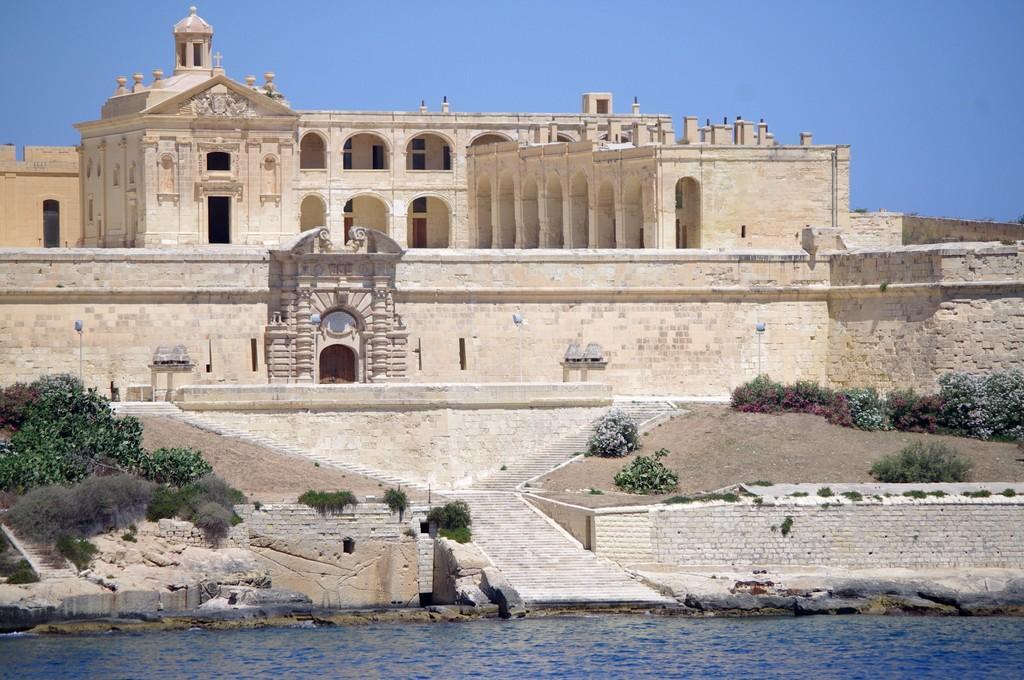Describe this image in one or two sentences. In the given image i can see a heritage building,plants,water,stairs and in the background i can see the sky. 